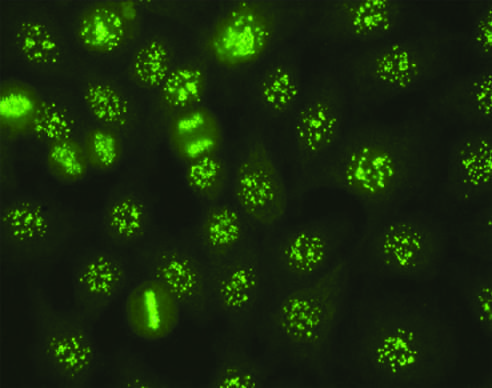what is seen in some cases of systemic sclerosis, sjogren syndrome, and other diseases?
Answer the question using a single word or phrase. The pattern of staining of anti-centromere antibodies diseases 